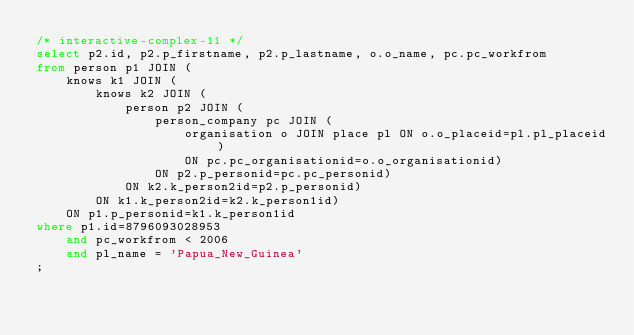Convert code to text. <code><loc_0><loc_0><loc_500><loc_500><_SQL_>/* interactive-complex-11 */
select p2.id, p2.p_firstname, p2.p_lastname, o.o_name, pc.pc_workfrom
from person p1 JOIN (
    knows k1 JOIN (
        knows k2 JOIN (
            person p2 JOIN (
                person_company pc JOIN (
                    organisation o JOIN place pl ON o.o_placeid=pl.pl_placeid)
                    ON pc.pc_organisationid=o.o_organisationid)
                ON p2.p_personid=pc.pc_personid)
            ON k2.k_person2id=p2.p_personid)
        ON k1.k_person2id=k2.k_person1id)
    ON p1.p_personid=k1.k_person1id
where p1.id=8796093028953
    and pc_workfrom < 2006
    and pl_name = 'Papua_New_Guinea'
;</code> 